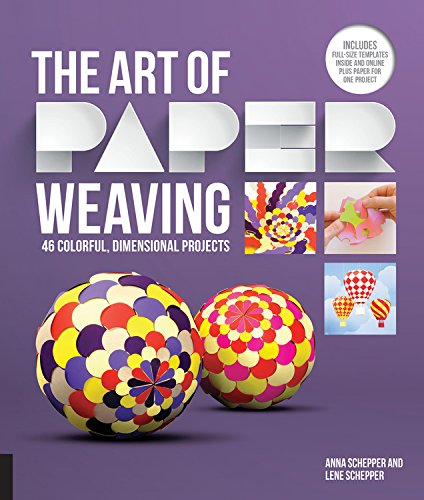Is this book related to Crafts, Hobbies & Home? Yes, this book is perfectly suited for those interested in the crafts and hobbies genre, particularly enthusiasts of paper craft. 